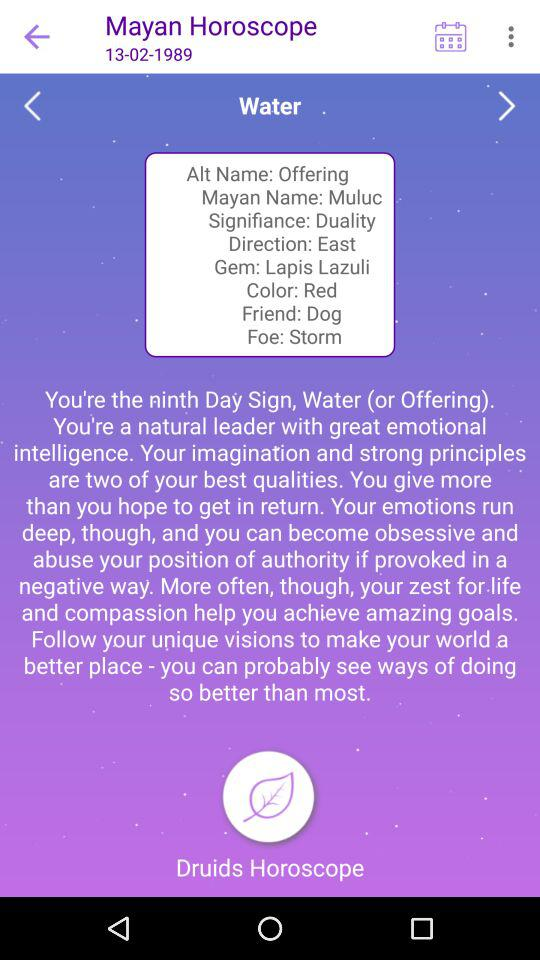What is the Mayan name? The Mayan name is Muluc. 